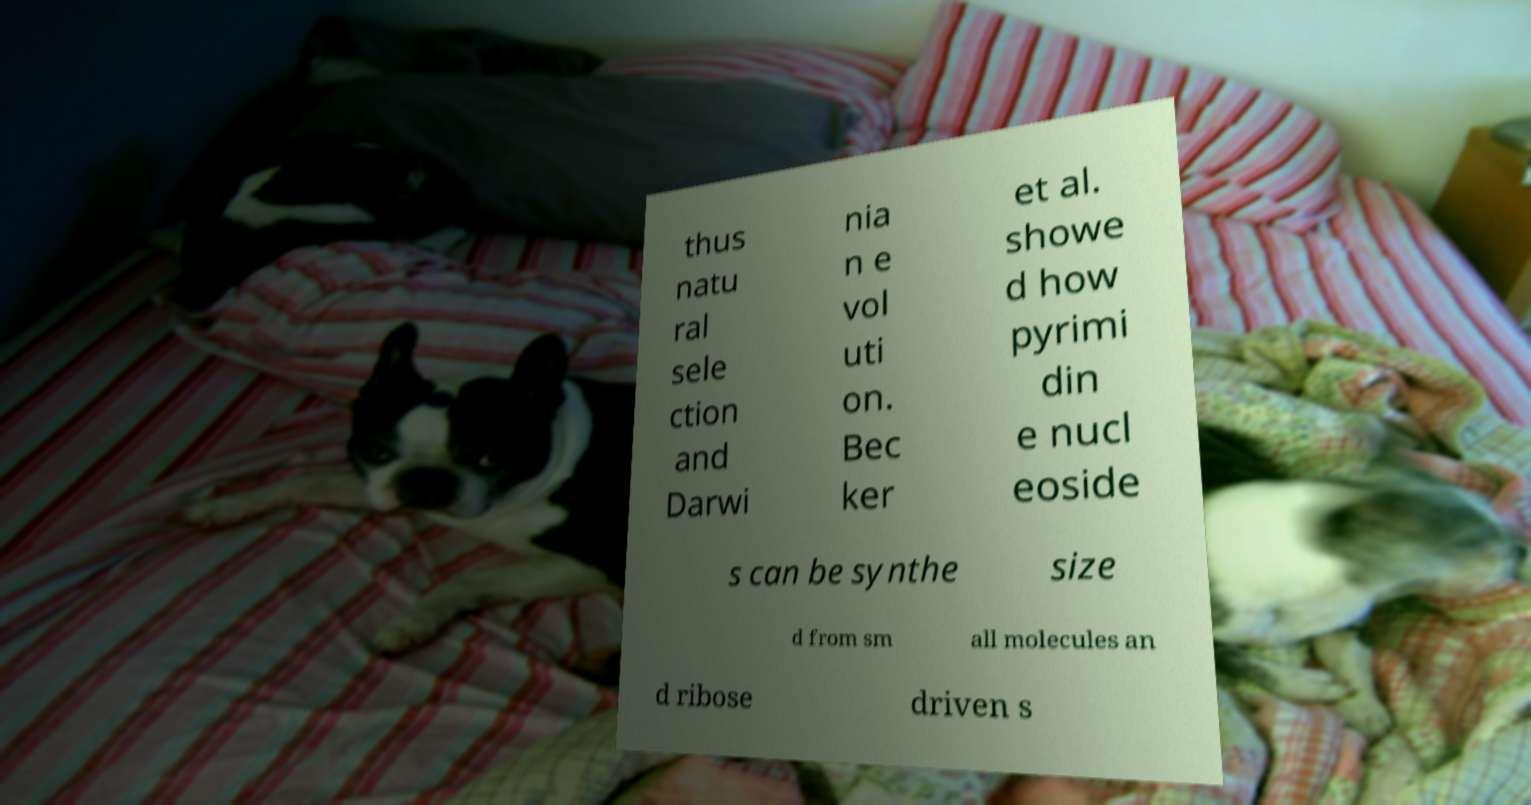Can you accurately transcribe the text from the provided image for me? thus natu ral sele ction and Darwi nia n e vol uti on. Bec ker et al. showe d how pyrimi din e nucl eoside s can be synthe size d from sm all molecules an d ribose driven s 